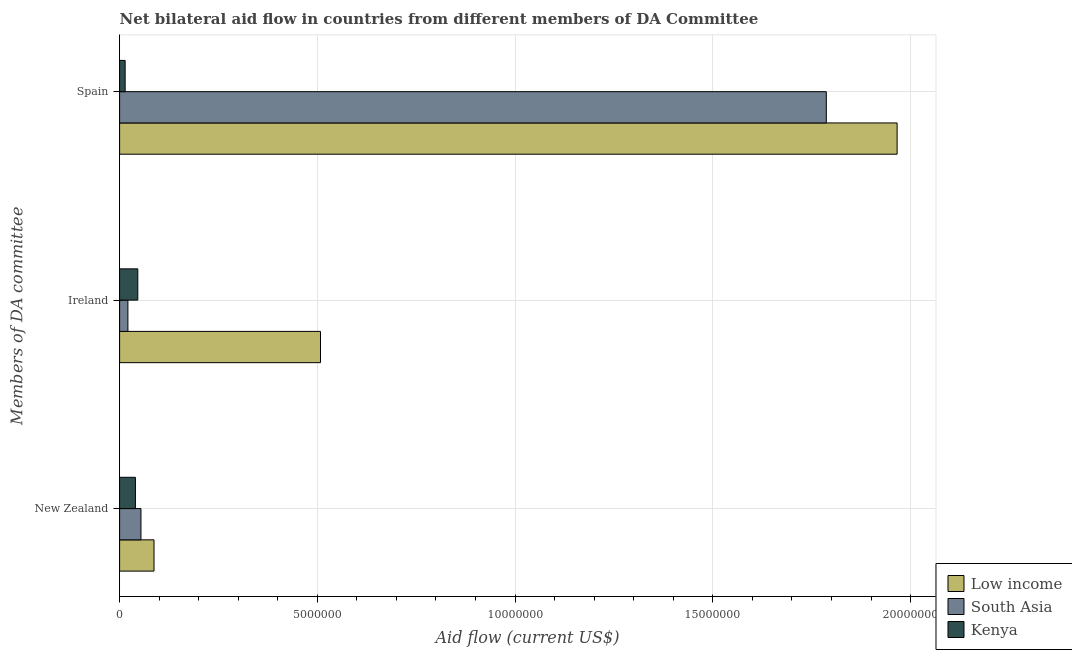How many groups of bars are there?
Your response must be concise. 3. Are the number of bars per tick equal to the number of legend labels?
Offer a very short reply. Yes. Are the number of bars on each tick of the Y-axis equal?
Make the answer very short. Yes. How many bars are there on the 2nd tick from the top?
Give a very brief answer. 3. How many bars are there on the 2nd tick from the bottom?
Your answer should be very brief. 3. What is the label of the 2nd group of bars from the top?
Your answer should be very brief. Ireland. What is the amount of aid provided by spain in Kenya?
Keep it short and to the point. 1.40e+05. Across all countries, what is the maximum amount of aid provided by spain?
Your answer should be compact. 1.97e+07. Across all countries, what is the minimum amount of aid provided by new zealand?
Your answer should be very brief. 4.00e+05. In which country was the amount of aid provided by new zealand minimum?
Your response must be concise. Kenya. What is the total amount of aid provided by ireland in the graph?
Your answer should be very brief. 5.75e+06. What is the difference between the amount of aid provided by ireland in South Asia and that in Kenya?
Your answer should be very brief. -2.50e+05. What is the difference between the amount of aid provided by spain in South Asia and the amount of aid provided by new zealand in Low income?
Ensure brevity in your answer.  1.70e+07. What is the average amount of aid provided by new zealand per country?
Offer a terse response. 6.03e+05. What is the difference between the amount of aid provided by ireland and amount of aid provided by new zealand in Low income?
Your response must be concise. 4.21e+06. What is the ratio of the amount of aid provided by ireland in Low income to that in Kenya?
Ensure brevity in your answer.  11.04. Is the difference between the amount of aid provided by spain in Kenya and Low income greater than the difference between the amount of aid provided by new zealand in Kenya and Low income?
Offer a very short reply. No. What is the difference between the highest and the second highest amount of aid provided by new zealand?
Offer a terse response. 3.30e+05. What is the difference between the highest and the lowest amount of aid provided by spain?
Provide a succinct answer. 1.95e+07. In how many countries, is the amount of aid provided by new zealand greater than the average amount of aid provided by new zealand taken over all countries?
Your answer should be very brief. 1. Is the sum of the amount of aid provided by spain in Low income and South Asia greater than the maximum amount of aid provided by ireland across all countries?
Your answer should be very brief. Yes. What does the 2nd bar from the top in Ireland represents?
Keep it short and to the point. South Asia. Are the values on the major ticks of X-axis written in scientific E-notation?
Provide a short and direct response. No. Does the graph contain grids?
Your answer should be very brief. Yes. What is the title of the graph?
Your answer should be compact. Net bilateral aid flow in countries from different members of DA Committee. Does "Mauritius" appear as one of the legend labels in the graph?
Provide a short and direct response. No. What is the label or title of the Y-axis?
Offer a terse response. Members of DA committee. What is the Aid flow (current US$) of Low income in New Zealand?
Your answer should be very brief. 8.70e+05. What is the Aid flow (current US$) of South Asia in New Zealand?
Keep it short and to the point. 5.40e+05. What is the Aid flow (current US$) of Kenya in New Zealand?
Provide a short and direct response. 4.00e+05. What is the Aid flow (current US$) of Low income in Ireland?
Offer a very short reply. 5.08e+06. What is the Aid flow (current US$) of Low income in Spain?
Make the answer very short. 1.97e+07. What is the Aid flow (current US$) in South Asia in Spain?
Provide a short and direct response. 1.79e+07. What is the Aid flow (current US$) in Kenya in Spain?
Offer a very short reply. 1.40e+05. Across all Members of DA committee, what is the maximum Aid flow (current US$) in Low income?
Your answer should be very brief. 1.97e+07. Across all Members of DA committee, what is the maximum Aid flow (current US$) in South Asia?
Your answer should be very brief. 1.79e+07. Across all Members of DA committee, what is the maximum Aid flow (current US$) of Kenya?
Your response must be concise. 4.60e+05. Across all Members of DA committee, what is the minimum Aid flow (current US$) of Low income?
Your response must be concise. 8.70e+05. Across all Members of DA committee, what is the minimum Aid flow (current US$) of South Asia?
Your answer should be very brief. 2.10e+05. What is the total Aid flow (current US$) in Low income in the graph?
Your response must be concise. 2.56e+07. What is the total Aid flow (current US$) of South Asia in the graph?
Give a very brief answer. 1.86e+07. What is the difference between the Aid flow (current US$) in Low income in New Zealand and that in Ireland?
Give a very brief answer. -4.21e+06. What is the difference between the Aid flow (current US$) in Kenya in New Zealand and that in Ireland?
Offer a very short reply. -6.00e+04. What is the difference between the Aid flow (current US$) in Low income in New Zealand and that in Spain?
Ensure brevity in your answer.  -1.88e+07. What is the difference between the Aid flow (current US$) of South Asia in New Zealand and that in Spain?
Your response must be concise. -1.73e+07. What is the difference between the Aid flow (current US$) in Low income in Ireland and that in Spain?
Offer a terse response. -1.46e+07. What is the difference between the Aid flow (current US$) of South Asia in Ireland and that in Spain?
Your response must be concise. -1.77e+07. What is the difference between the Aid flow (current US$) in Kenya in Ireland and that in Spain?
Keep it short and to the point. 3.20e+05. What is the difference between the Aid flow (current US$) in Low income in New Zealand and the Aid flow (current US$) in Kenya in Ireland?
Provide a short and direct response. 4.10e+05. What is the difference between the Aid flow (current US$) in Low income in New Zealand and the Aid flow (current US$) in South Asia in Spain?
Offer a terse response. -1.70e+07. What is the difference between the Aid flow (current US$) in Low income in New Zealand and the Aid flow (current US$) in Kenya in Spain?
Provide a succinct answer. 7.30e+05. What is the difference between the Aid flow (current US$) in Low income in Ireland and the Aid flow (current US$) in South Asia in Spain?
Your answer should be compact. -1.28e+07. What is the difference between the Aid flow (current US$) of Low income in Ireland and the Aid flow (current US$) of Kenya in Spain?
Your response must be concise. 4.94e+06. What is the difference between the Aid flow (current US$) in South Asia in Ireland and the Aid flow (current US$) in Kenya in Spain?
Give a very brief answer. 7.00e+04. What is the average Aid flow (current US$) of Low income per Members of DA committee?
Provide a succinct answer. 8.54e+06. What is the average Aid flow (current US$) in South Asia per Members of DA committee?
Ensure brevity in your answer.  6.21e+06. What is the average Aid flow (current US$) of Kenya per Members of DA committee?
Give a very brief answer. 3.33e+05. What is the difference between the Aid flow (current US$) in Low income and Aid flow (current US$) in South Asia in New Zealand?
Your answer should be very brief. 3.30e+05. What is the difference between the Aid flow (current US$) of Low income and Aid flow (current US$) of South Asia in Ireland?
Your answer should be compact. 4.87e+06. What is the difference between the Aid flow (current US$) of Low income and Aid flow (current US$) of Kenya in Ireland?
Provide a short and direct response. 4.62e+06. What is the difference between the Aid flow (current US$) in Low income and Aid flow (current US$) in South Asia in Spain?
Give a very brief answer. 1.79e+06. What is the difference between the Aid flow (current US$) in Low income and Aid flow (current US$) in Kenya in Spain?
Your response must be concise. 1.95e+07. What is the difference between the Aid flow (current US$) of South Asia and Aid flow (current US$) of Kenya in Spain?
Provide a short and direct response. 1.77e+07. What is the ratio of the Aid flow (current US$) of Low income in New Zealand to that in Ireland?
Give a very brief answer. 0.17. What is the ratio of the Aid flow (current US$) of South Asia in New Zealand to that in Ireland?
Your response must be concise. 2.57. What is the ratio of the Aid flow (current US$) of Kenya in New Zealand to that in Ireland?
Your answer should be very brief. 0.87. What is the ratio of the Aid flow (current US$) of Low income in New Zealand to that in Spain?
Provide a short and direct response. 0.04. What is the ratio of the Aid flow (current US$) in South Asia in New Zealand to that in Spain?
Keep it short and to the point. 0.03. What is the ratio of the Aid flow (current US$) of Kenya in New Zealand to that in Spain?
Give a very brief answer. 2.86. What is the ratio of the Aid flow (current US$) in Low income in Ireland to that in Spain?
Offer a terse response. 0.26. What is the ratio of the Aid flow (current US$) of South Asia in Ireland to that in Spain?
Keep it short and to the point. 0.01. What is the ratio of the Aid flow (current US$) in Kenya in Ireland to that in Spain?
Provide a succinct answer. 3.29. What is the difference between the highest and the second highest Aid flow (current US$) in Low income?
Your answer should be very brief. 1.46e+07. What is the difference between the highest and the second highest Aid flow (current US$) of South Asia?
Your response must be concise. 1.73e+07. What is the difference between the highest and the lowest Aid flow (current US$) in Low income?
Make the answer very short. 1.88e+07. What is the difference between the highest and the lowest Aid flow (current US$) of South Asia?
Offer a terse response. 1.77e+07. 